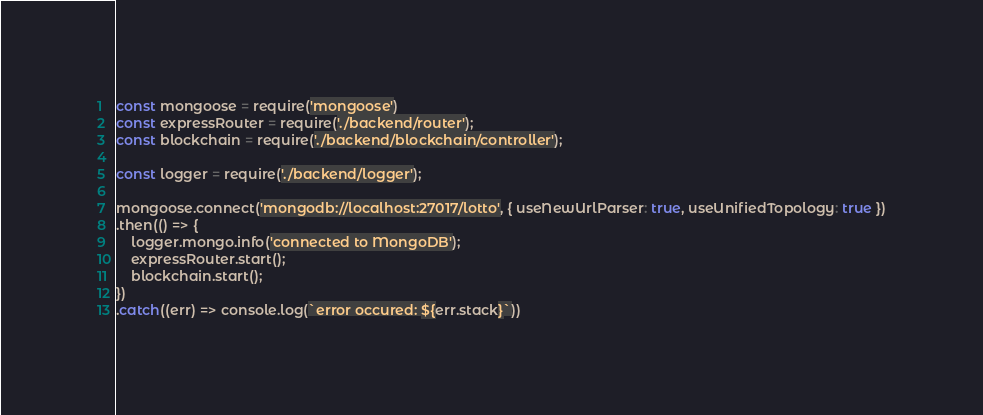<code> <loc_0><loc_0><loc_500><loc_500><_JavaScript_>const mongoose = require('mongoose')
const expressRouter = require('./backend/router');
const blockchain = require('./backend/blockchain/controller');

const logger = require('./backend/logger');

mongoose.connect('mongodb://localhost:27017/lotto', { useNewUrlParser: true, useUnifiedTopology: true })
.then(() => {
    logger.mongo.info('connected to MongoDB');
    expressRouter.start();
    blockchain.start();
})
.catch((err) => console.log(`error occured: ${err.stack}`))</code> 